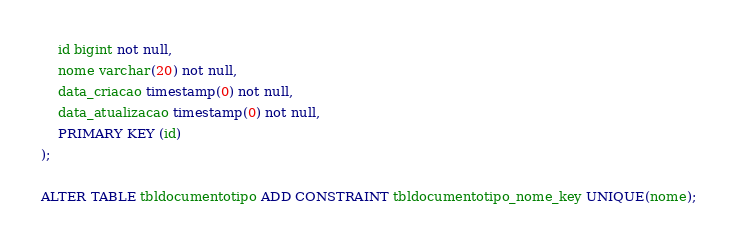<code> <loc_0><loc_0><loc_500><loc_500><_SQL_>    id bigint not null,
    nome varchar(20) not null,
    data_criacao timestamp(0) not null,
    data_atualizacao timestamp(0) not null,
    PRIMARY KEY (id)
);

ALTER TABLE tbldocumentotipo ADD CONSTRAINT tbldocumentotipo_nome_key UNIQUE(nome);
</code> 